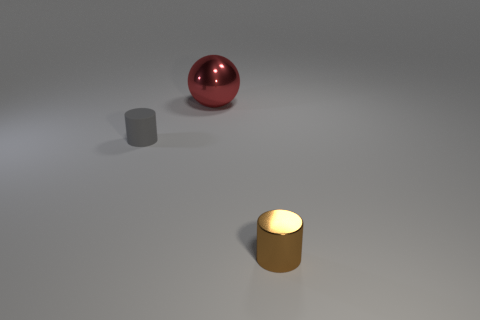What color is the object that is to the right of the red metallic thing?
Your response must be concise. Brown. How many large things are behind the cylinder to the left of the red metal sphere?
Provide a succinct answer. 1. Is the size of the metal cylinder the same as the cylinder that is behind the tiny brown object?
Ensure brevity in your answer.  Yes. Are there any brown metal things of the same size as the brown cylinder?
Make the answer very short. No. What number of objects are tiny brown shiny cylinders or tiny green blocks?
Ensure brevity in your answer.  1. There is a metallic thing that is behind the rubber cylinder; is it the same size as the metallic object in front of the gray cylinder?
Ensure brevity in your answer.  No. Are there any other tiny metal objects that have the same shape as the small metal object?
Keep it short and to the point. No. Are there fewer red balls in front of the tiny gray rubber cylinder than rubber cylinders?
Your answer should be very brief. Yes. Is the shape of the rubber thing the same as the large red object?
Keep it short and to the point. No. There is a shiny object behind the brown metal thing; what size is it?
Provide a succinct answer. Large. 